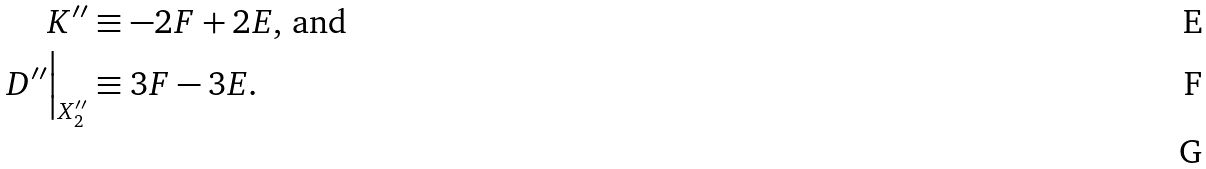Convert formula to latex. <formula><loc_0><loc_0><loc_500><loc_500>K ^ { \prime \prime } & \equiv - 2 F + 2 E \text {, and} \\ D ^ { \prime \prime } \Big | _ { X _ { 2 } ^ { \prime \prime } } & \equiv 3 F - 3 E . \\</formula> 